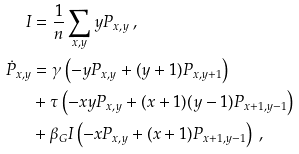Convert formula to latex. <formula><loc_0><loc_0><loc_500><loc_500>I & = \frac { 1 } { n } \sum _ { x , y } y P _ { x , y } \text { ,} \\ \dot { P } _ { x , y } & = \gamma \left ( - y P _ { x , y } + ( y + 1 ) P _ { x , y + 1 } \right ) \\ & + \tau \left ( - x y P _ { x , y } + ( x + 1 ) ( y - 1 ) P _ { x + 1 , y - 1 } \right ) \\ & + \beta _ { G } I \left ( - x P _ { x , y } + ( x + 1 ) P _ { x + 1 , y - 1 } \right ) \text { ,}</formula> 